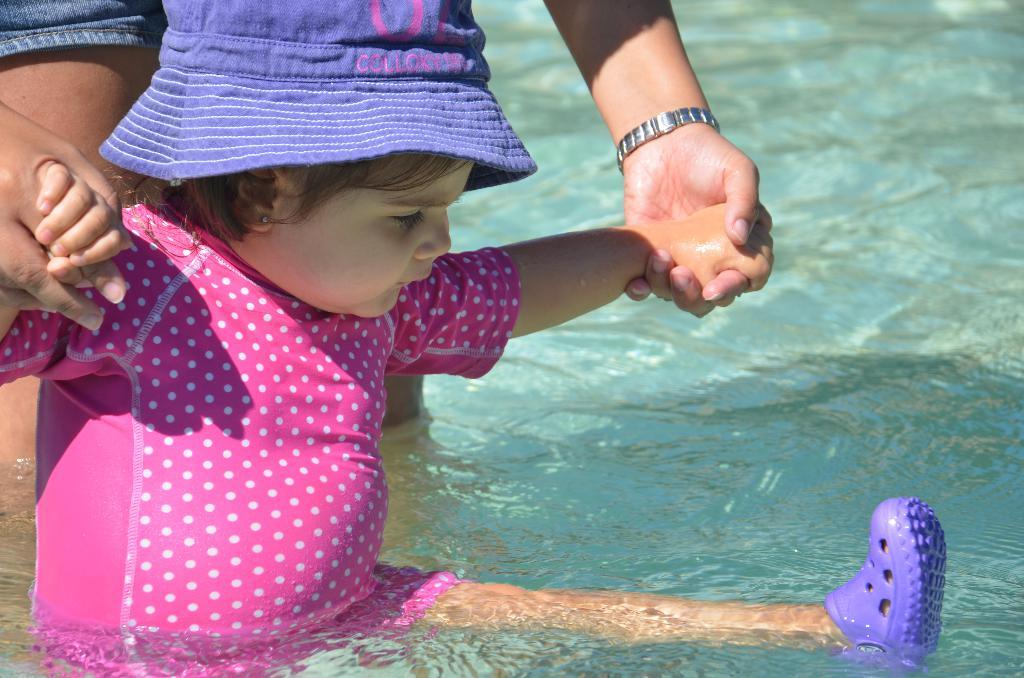What is the baby doing in the image? The baby is in the water in the image. What is the baby wearing? The baby is wearing a pink dress, a purple cap, and purple shoes. Are there any other people present in the image? Yes, there are other people standing in the background. What type of bulb can be seen lighting up the area in the image? There is no bulb present in the image; it features a baby in the water. How many cattle are visible in the image? There are no cattle present in the image. 